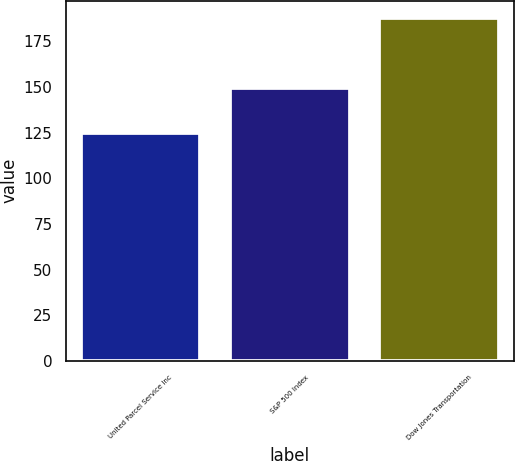Convert chart. <chart><loc_0><loc_0><loc_500><loc_500><bar_chart><fcel>United Parcel Service Inc<fcel>S&P 500 Index<fcel>Dow Jones Transportation<nl><fcel>124.88<fcel>149.69<fcel>188<nl></chart> 